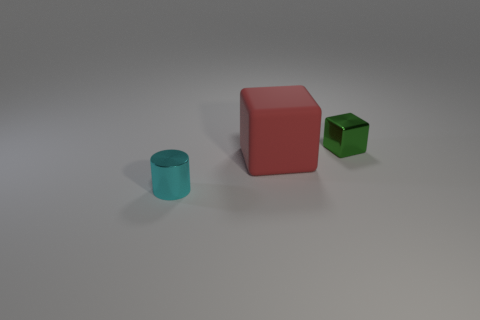Are there any other things that have the same shape as the large red object?
Make the answer very short. Yes. What is the small object that is in front of the green thing made of?
Provide a short and direct response. Metal. What size is the red thing that is the same shape as the small green metallic object?
Offer a terse response. Large. What number of small cubes are made of the same material as the cylinder?
Make the answer very short. 1. What number of things are small things on the right side of the small metal cylinder or cylinders on the left side of the large rubber thing?
Provide a short and direct response. 2. Is the number of large things in front of the matte thing less than the number of brown shiny spheres?
Give a very brief answer. No. Is there a cube that has the same size as the cyan cylinder?
Offer a very short reply. Yes. The cylinder is what color?
Provide a short and direct response. Cyan. Is the size of the green cube the same as the red thing?
Your response must be concise. No. What number of things are either small cyan things or tiny brown things?
Ensure brevity in your answer.  1. 